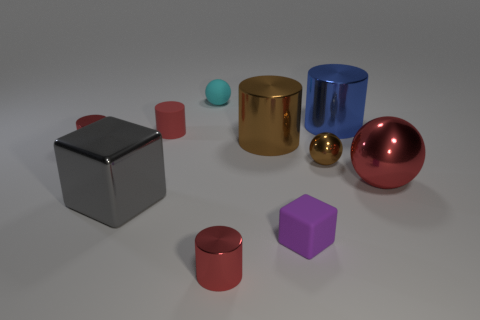Describe the lighting and shadows in the scene. The lighting in the scene seems to be coming from above, casting soft shadows directly under the objects. There's a gentle gradient of light, suggesting a possibly diffused source. The shadows are not very sharp, which indicates the light is not intense or directly overhead, and it creates a calm atmosphere for the display of the objects. 